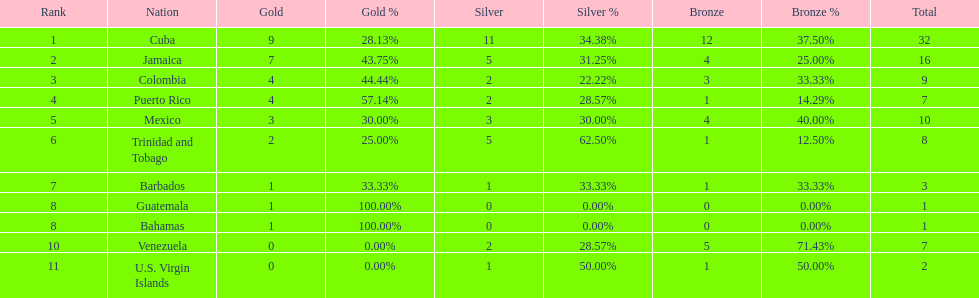What is the total number of gold medals awarded between these 11 countries? 32. 